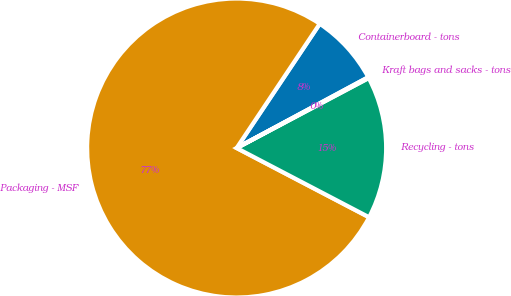Convert chart. <chart><loc_0><loc_0><loc_500><loc_500><pie_chart><fcel>Containerboard - tons<fcel>Packaging - MSF<fcel>Recycling - tons<fcel>Kraft bags and sacks - tons<nl><fcel>7.76%<fcel>76.71%<fcel>15.42%<fcel>0.1%<nl></chart> 